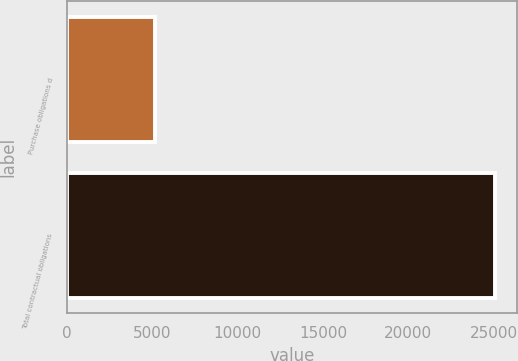Convert chart to OTSL. <chart><loc_0><loc_0><loc_500><loc_500><bar_chart><fcel>Purchase obligations d<fcel>Total contractual obligations<nl><fcel>5137<fcel>25096<nl></chart> 